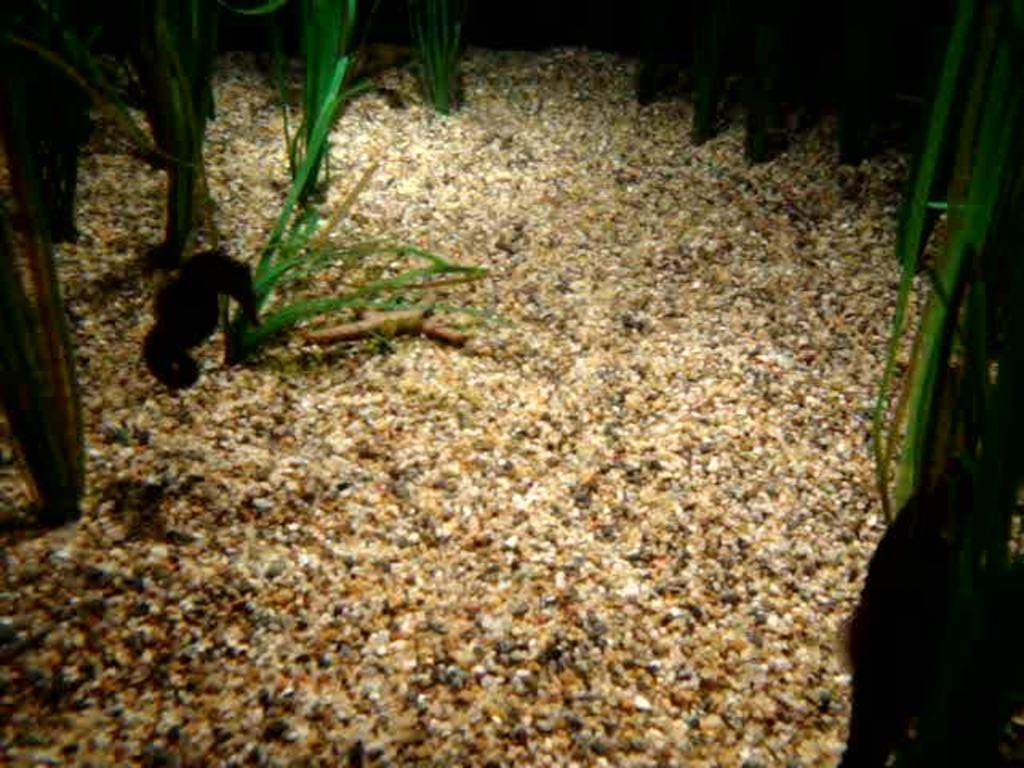What is depicted on the ground in the image? There are planets depicted on the ground in the image. What time of day was the image taken? The image was taken during nighttime. What type of footwear is visible on the planets in the image? There is no footwear visible on the planets in the image, as they are celestial bodies and not people wearing shoes. 